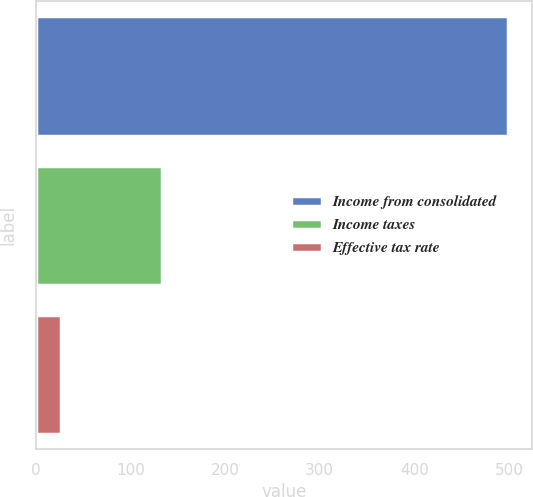<chart> <loc_0><loc_0><loc_500><loc_500><bar_chart><fcel>Income from consolidated<fcel>Income taxes<fcel>Effective tax rate<nl><fcel>499.4<fcel>133.6<fcel>26.8<nl></chart> 